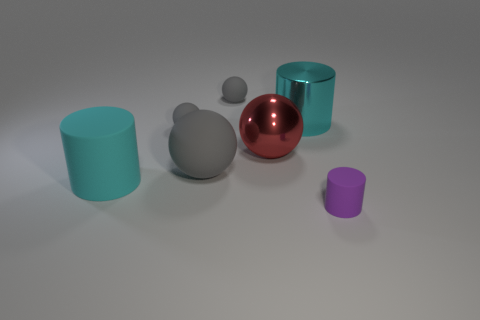Subtract all big cyan metal cylinders. How many cylinders are left? 2 Add 1 matte things. How many objects exist? 8 Subtract all purple cylinders. How many cylinders are left? 2 Subtract 3 cylinders. How many cylinders are left? 0 Subtract all red cubes. How many cyan cylinders are left? 2 Add 7 big cyan matte objects. How many big cyan matte objects exist? 8 Subtract 0 cyan blocks. How many objects are left? 7 Subtract all cylinders. How many objects are left? 4 Subtract all green cylinders. Subtract all green cubes. How many cylinders are left? 3 Subtract all large cyan things. Subtract all small rubber objects. How many objects are left? 2 